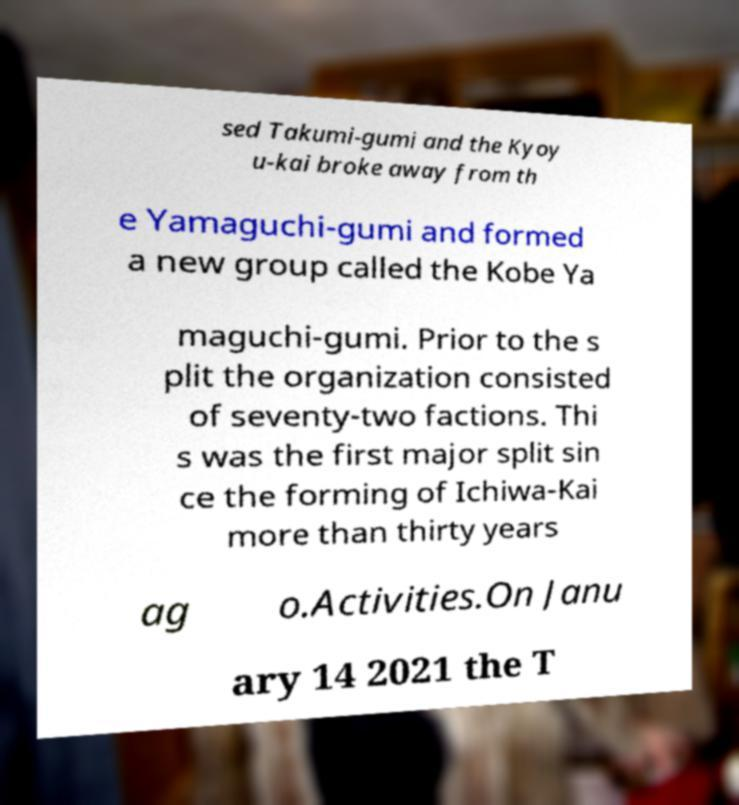I need the written content from this picture converted into text. Can you do that? sed Takumi-gumi and the Kyoy u-kai broke away from th e Yamaguchi-gumi and formed a new group called the Kobe Ya maguchi-gumi. Prior to the s plit the organization consisted of seventy-two factions. Thi s was the first major split sin ce the forming of Ichiwa-Kai more than thirty years ag o.Activities.On Janu ary 14 2021 the T 